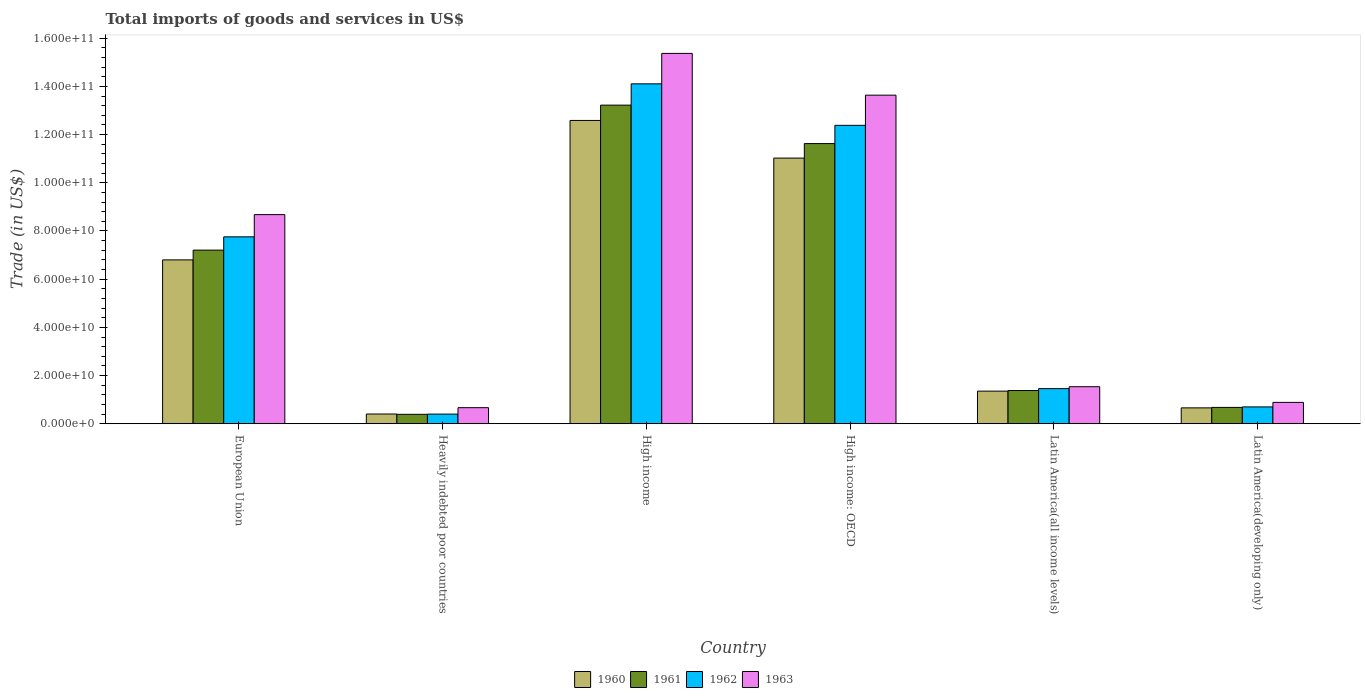Are the number of bars per tick equal to the number of legend labels?
Provide a short and direct response. Yes. Are the number of bars on each tick of the X-axis equal?
Offer a very short reply. Yes. How many bars are there on the 6th tick from the right?
Your answer should be very brief. 4. What is the label of the 5th group of bars from the left?
Your response must be concise. Latin America(all income levels). In how many cases, is the number of bars for a given country not equal to the number of legend labels?
Your response must be concise. 0. What is the total imports of goods and services in 1963 in High income: OECD?
Make the answer very short. 1.36e+11. Across all countries, what is the maximum total imports of goods and services in 1961?
Offer a very short reply. 1.32e+11. Across all countries, what is the minimum total imports of goods and services in 1963?
Ensure brevity in your answer.  6.67e+09. In which country was the total imports of goods and services in 1961 maximum?
Your response must be concise. High income. In which country was the total imports of goods and services in 1961 minimum?
Make the answer very short. Heavily indebted poor countries. What is the total total imports of goods and services in 1962 in the graph?
Provide a short and direct response. 3.68e+11. What is the difference between the total imports of goods and services in 1961 in European Union and that in High income?
Give a very brief answer. -6.02e+1. What is the difference between the total imports of goods and services in 1963 in European Union and the total imports of goods and services in 1960 in Latin America(developing only)?
Your answer should be compact. 8.02e+1. What is the average total imports of goods and services in 1962 per country?
Give a very brief answer. 6.13e+1. What is the difference between the total imports of goods and services of/in 1960 and total imports of goods and services of/in 1962 in High income: OECD?
Provide a succinct answer. -1.36e+1. In how many countries, is the total imports of goods and services in 1961 greater than 84000000000 US$?
Give a very brief answer. 2. What is the ratio of the total imports of goods and services in 1963 in European Union to that in Latin America(developing only)?
Give a very brief answer. 9.79. Is the difference between the total imports of goods and services in 1960 in European Union and Latin America(all income levels) greater than the difference between the total imports of goods and services in 1962 in European Union and Latin America(all income levels)?
Give a very brief answer. No. What is the difference between the highest and the second highest total imports of goods and services in 1962?
Offer a terse response. -1.72e+1. What is the difference between the highest and the lowest total imports of goods and services in 1963?
Your response must be concise. 1.47e+11. Is the sum of the total imports of goods and services in 1961 in High income and Latin America(all income levels) greater than the maximum total imports of goods and services in 1962 across all countries?
Offer a very short reply. Yes. Is it the case that in every country, the sum of the total imports of goods and services in 1962 and total imports of goods and services in 1960 is greater than the sum of total imports of goods and services in 1961 and total imports of goods and services in 1963?
Your response must be concise. No. What does the 3rd bar from the left in European Union represents?
Offer a very short reply. 1962. What does the 2nd bar from the right in Heavily indebted poor countries represents?
Your response must be concise. 1962. How many bars are there?
Offer a terse response. 24. How many countries are there in the graph?
Offer a very short reply. 6. Are the values on the major ticks of Y-axis written in scientific E-notation?
Keep it short and to the point. Yes. How many legend labels are there?
Offer a very short reply. 4. What is the title of the graph?
Provide a short and direct response. Total imports of goods and services in US$. What is the label or title of the Y-axis?
Your answer should be very brief. Trade (in US$). What is the Trade (in US$) of 1960 in European Union?
Your response must be concise. 6.80e+1. What is the Trade (in US$) of 1961 in European Union?
Your response must be concise. 7.21e+1. What is the Trade (in US$) of 1962 in European Union?
Keep it short and to the point. 7.76e+1. What is the Trade (in US$) in 1963 in European Union?
Your answer should be very brief. 8.68e+1. What is the Trade (in US$) of 1960 in Heavily indebted poor countries?
Offer a terse response. 4.04e+09. What is the Trade (in US$) in 1961 in Heavily indebted poor countries?
Keep it short and to the point. 3.91e+09. What is the Trade (in US$) of 1962 in Heavily indebted poor countries?
Keep it short and to the point. 4.00e+09. What is the Trade (in US$) in 1963 in Heavily indebted poor countries?
Keep it short and to the point. 6.67e+09. What is the Trade (in US$) of 1960 in High income?
Give a very brief answer. 1.26e+11. What is the Trade (in US$) of 1961 in High income?
Your answer should be very brief. 1.32e+11. What is the Trade (in US$) of 1962 in High income?
Your response must be concise. 1.41e+11. What is the Trade (in US$) of 1963 in High income?
Offer a terse response. 1.54e+11. What is the Trade (in US$) of 1960 in High income: OECD?
Your response must be concise. 1.10e+11. What is the Trade (in US$) in 1961 in High income: OECD?
Give a very brief answer. 1.16e+11. What is the Trade (in US$) in 1962 in High income: OECD?
Your answer should be very brief. 1.24e+11. What is the Trade (in US$) of 1963 in High income: OECD?
Ensure brevity in your answer.  1.36e+11. What is the Trade (in US$) in 1960 in Latin America(all income levels)?
Ensure brevity in your answer.  1.35e+1. What is the Trade (in US$) of 1961 in Latin America(all income levels)?
Your answer should be compact. 1.38e+1. What is the Trade (in US$) in 1962 in Latin America(all income levels)?
Offer a terse response. 1.46e+1. What is the Trade (in US$) in 1963 in Latin America(all income levels)?
Make the answer very short. 1.54e+1. What is the Trade (in US$) of 1960 in Latin America(developing only)?
Provide a short and direct response. 6.59e+09. What is the Trade (in US$) in 1961 in Latin America(developing only)?
Your response must be concise. 6.78e+09. What is the Trade (in US$) of 1962 in Latin America(developing only)?
Make the answer very short. 6.99e+09. What is the Trade (in US$) in 1963 in Latin America(developing only)?
Offer a terse response. 8.86e+09. Across all countries, what is the maximum Trade (in US$) in 1960?
Keep it short and to the point. 1.26e+11. Across all countries, what is the maximum Trade (in US$) of 1961?
Offer a very short reply. 1.32e+11. Across all countries, what is the maximum Trade (in US$) in 1962?
Provide a short and direct response. 1.41e+11. Across all countries, what is the maximum Trade (in US$) of 1963?
Provide a succinct answer. 1.54e+11. Across all countries, what is the minimum Trade (in US$) of 1960?
Give a very brief answer. 4.04e+09. Across all countries, what is the minimum Trade (in US$) of 1961?
Your answer should be very brief. 3.91e+09. Across all countries, what is the minimum Trade (in US$) in 1962?
Your answer should be very brief. 4.00e+09. Across all countries, what is the minimum Trade (in US$) of 1963?
Your answer should be compact. 6.67e+09. What is the total Trade (in US$) of 1960 in the graph?
Give a very brief answer. 3.28e+11. What is the total Trade (in US$) of 1961 in the graph?
Offer a terse response. 3.45e+11. What is the total Trade (in US$) of 1962 in the graph?
Your answer should be compact. 3.68e+11. What is the total Trade (in US$) in 1963 in the graph?
Your response must be concise. 4.08e+11. What is the difference between the Trade (in US$) in 1960 in European Union and that in Heavily indebted poor countries?
Give a very brief answer. 6.40e+1. What is the difference between the Trade (in US$) in 1961 in European Union and that in Heavily indebted poor countries?
Your response must be concise. 6.82e+1. What is the difference between the Trade (in US$) in 1962 in European Union and that in Heavily indebted poor countries?
Provide a short and direct response. 7.36e+1. What is the difference between the Trade (in US$) in 1963 in European Union and that in Heavily indebted poor countries?
Ensure brevity in your answer.  8.01e+1. What is the difference between the Trade (in US$) of 1960 in European Union and that in High income?
Offer a very short reply. -5.79e+1. What is the difference between the Trade (in US$) of 1961 in European Union and that in High income?
Offer a very short reply. -6.02e+1. What is the difference between the Trade (in US$) of 1962 in European Union and that in High income?
Provide a short and direct response. -6.35e+1. What is the difference between the Trade (in US$) of 1963 in European Union and that in High income?
Your response must be concise. -6.69e+1. What is the difference between the Trade (in US$) of 1960 in European Union and that in High income: OECD?
Make the answer very short. -4.23e+1. What is the difference between the Trade (in US$) of 1961 in European Union and that in High income: OECD?
Give a very brief answer. -4.42e+1. What is the difference between the Trade (in US$) of 1962 in European Union and that in High income: OECD?
Your answer should be very brief. -4.63e+1. What is the difference between the Trade (in US$) of 1963 in European Union and that in High income: OECD?
Keep it short and to the point. -4.96e+1. What is the difference between the Trade (in US$) of 1960 in European Union and that in Latin America(all income levels)?
Keep it short and to the point. 5.45e+1. What is the difference between the Trade (in US$) of 1961 in European Union and that in Latin America(all income levels)?
Keep it short and to the point. 5.83e+1. What is the difference between the Trade (in US$) in 1962 in European Union and that in Latin America(all income levels)?
Give a very brief answer. 6.30e+1. What is the difference between the Trade (in US$) in 1963 in European Union and that in Latin America(all income levels)?
Make the answer very short. 7.14e+1. What is the difference between the Trade (in US$) in 1960 in European Union and that in Latin America(developing only)?
Make the answer very short. 6.14e+1. What is the difference between the Trade (in US$) of 1961 in European Union and that in Latin America(developing only)?
Your answer should be very brief. 6.53e+1. What is the difference between the Trade (in US$) of 1962 in European Union and that in Latin America(developing only)?
Provide a short and direct response. 7.06e+1. What is the difference between the Trade (in US$) in 1963 in European Union and that in Latin America(developing only)?
Ensure brevity in your answer.  7.79e+1. What is the difference between the Trade (in US$) in 1960 in Heavily indebted poor countries and that in High income?
Give a very brief answer. -1.22e+11. What is the difference between the Trade (in US$) of 1961 in Heavily indebted poor countries and that in High income?
Keep it short and to the point. -1.28e+11. What is the difference between the Trade (in US$) of 1962 in Heavily indebted poor countries and that in High income?
Your answer should be very brief. -1.37e+11. What is the difference between the Trade (in US$) of 1963 in Heavily indebted poor countries and that in High income?
Give a very brief answer. -1.47e+11. What is the difference between the Trade (in US$) of 1960 in Heavily indebted poor countries and that in High income: OECD?
Make the answer very short. -1.06e+11. What is the difference between the Trade (in US$) of 1961 in Heavily indebted poor countries and that in High income: OECD?
Your response must be concise. -1.12e+11. What is the difference between the Trade (in US$) in 1962 in Heavily indebted poor countries and that in High income: OECD?
Your response must be concise. -1.20e+11. What is the difference between the Trade (in US$) in 1963 in Heavily indebted poor countries and that in High income: OECD?
Your response must be concise. -1.30e+11. What is the difference between the Trade (in US$) in 1960 in Heavily indebted poor countries and that in Latin America(all income levels)?
Your answer should be compact. -9.49e+09. What is the difference between the Trade (in US$) of 1961 in Heavily indebted poor countries and that in Latin America(all income levels)?
Give a very brief answer. -9.87e+09. What is the difference between the Trade (in US$) of 1962 in Heavily indebted poor countries and that in Latin America(all income levels)?
Your answer should be very brief. -1.06e+1. What is the difference between the Trade (in US$) of 1963 in Heavily indebted poor countries and that in Latin America(all income levels)?
Offer a very short reply. -8.70e+09. What is the difference between the Trade (in US$) in 1960 in Heavily indebted poor countries and that in Latin America(developing only)?
Keep it short and to the point. -2.55e+09. What is the difference between the Trade (in US$) of 1961 in Heavily indebted poor countries and that in Latin America(developing only)?
Offer a terse response. -2.87e+09. What is the difference between the Trade (in US$) of 1962 in Heavily indebted poor countries and that in Latin America(developing only)?
Your response must be concise. -2.99e+09. What is the difference between the Trade (in US$) of 1963 in Heavily indebted poor countries and that in Latin America(developing only)?
Your response must be concise. -2.20e+09. What is the difference between the Trade (in US$) of 1960 in High income and that in High income: OECD?
Your answer should be very brief. 1.56e+1. What is the difference between the Trade (in US$) in 1961 in High income and that in High income: OECD?
Give a very brief answer. 1.60e+1. What is the difference between the Trade (in US$) in 1962 in High income and that in High income: OECD?
Ensure brevity in your answer.  1.72e+1. What is the difference between the Trade (in US$) of 1963 in High income and that in High income: OECD?
Provide a succinct answer. 1.73e+1. What is the difference between the Trade (in US$) of 1960 in High income and that in Latin America(all income levels)?
Offer a very short reply. 1.12e+11. What is the difference between the Trade (in US$) in 1961 in High income and that in Latin America(all income levels)?
Make the answer very short. 1.18e+11. What is the difference between the Trade (in US$) in 1962 in High income and that in Latin America(all income levels)?
Offer a terse response. 1.26e+11. What is the difference between the Trade (in US$) of 1963 in High income and that in Latin America(all income levels)?
Offer a very short reply. 1.38e+11. What is the difference between the Trade (in US$) of 1960 in High income and that in Latin America(developing only)?
Ensure brevity in your answer.  1.19e+11. What is the difference between the Trade (in US$) of 1961 in High income and that in Latin America(developing only)?
Offer a very short reply. 1.25e+11. What is the difference between the Trade (in US$) of 1962 in High income and that in Latin America(developing only)?
Your response must be concise. 1.34e+11. What is the difference between the Trade (in US$) of 1963 in High income and that in Latin America(developing only)?
Provide a succinct answer. 1.45e+11. What is the difference between the Trade (in US$) of 1960 in High income: OECD and that in Latin America(all income levels)?
Your answer should be compact. 9.67e+1. What is the difference between the Trade (in US$) in 1961 in High income: OECD and that in Latin America(all income levels)?
Keep it short and to the point. 1.02e+11. What is the difference between the Trade (in US$) of 1962 in High income: OECD and that in Latin America(all income levels)?
Offer a very short reply. 1.09e+11. What is the difference between the Trade (in US$) in 1963 in High income: OECD and that in Latin America(all income levels)?
Make the answer very short. 1.21e+11. What is the difference between the Trade (in US$) in 1960 in High income: OECD and that in Latin America(developing only)?
Provide a short and direct response. 1.04e+11. What is the difference between the Trade (in US$) of 1961 in High income: OECD and that in Latin America(developing only)?
Provide a short and direct response. 1.09e+11. What is the difference between the Trade (in US$) of 1962 in High income: OECD and that in Latin America(developing only)?
Keep it short and to the point. 1.17e+11. What is the difference between the Trade (in US$) of 1963 in High income: OECD and that in Latin America(developing only)?
Your answer should be very brief. 1.28e+11. What is the difference between the Trade (in US$) of 1960 in Latin America(all income levels) and that in Latin America(developing only)?
Give a very brief answer. 6.94e+09. What is the difference between the Trade (in US$) in 1961 in Latin America(all income levels) and that in Latin America(developing only)?
Your answer should be very brief. 7.00e+09. What is the difference between the Trade (in US$) of 1962 in Latin America(all income levels) and that in Latin America(developing only)?
Ensure brevity in your answer.  7.59e+09. What is the difference between the Trade (in US$) in 1963 in Latin America(all income levels) and that in Latin America(developing only)?
Your answer should be very brief. 6.50e+09. What is the difference between the Trade (in US$) in 1960 in European Union and the Trade (in US$) in 1961 in Heavily indebted poor countries?
Ensure brevity in your answer.  6.41e+1. What is the difference between the Trade (in US$) of 1960 in European Union and the Trade (in US$) of 1962 in Heavily indebted poor countries?
Provide a short and direct response. 6.40e+1. What is the difference between the Trade (in US$) of 1960 in European Union and the Trade (in US$) of 1963 in Heavily indebted poor countries?
Offer a very short reply. 6.13e+1. What is the difference between the Trade (in US$) in 1961 in European Union and the Trade (in US$) in 1962 in Heavily indebted poor countries?
Your response must be concise. 6.81e+1. What is the difference between the Trade (in US$) in 1961 in European Union and the Trade (in US$) in 1963 in Heavily indebted poor countries?
Your answer should be compact. 6.54e+1. What is the difference between the Trade (in US$) of 1962 in European Union and the Trade (in US$) of 1963 in Heavily indebted poor countries?
Ensure brevity in your answer.  7.09e+1. What is the difference between the Trade (in US$) in 1960 in European Union and the Trade (in US$) in 1961 in High income?
Offer a very short reply. -6.42e+1. What is the difference between the Trade (in US$) of 1960 in European Union and the Trade (in US$) of 1962 in High income?
Offer a terse response. -7.31e+1. What is the difference between the Trade (in US$) of 1960 in European Union and the Trade (in US$) of 1963 in High income?
Keep it short and to the point. -8.57e+1. What is the difference between the Trade (in US$) in 1961 in European Union and the Trade (in US$) in 1962 in High income?
Offer a terse response. -6.90e+1. What is the difference between the Trade (in US$) in 1961 in European Union and the Trade (in US$) in 1963 in High income?
Keep it short and to the point. -8.16e+1. What is the difference between the Trade (in US$) of 1962 in European Union and the Trade (in US$) of 1963 in High income?
Your answer should be very brief. -7.61e+1. What is the difference between the Trade (in US$) in 1960 in European Union and the Trade (in US$) in 1961 in High income: OECD?
Provide a succinct answer. -4.83e+1. What is the difference between the Trade (in US$) of 1960 in European Union and the Trade (in US$) of 1962 in High income: OECD?
Your answer should be very brief. -5.58e+1. What is the difference between the Trade (in US$) of 1960 in European Union and the Trade (in US$) of 1963 in High income: OECD?
Your answer should be compact. -6.84e+1. What is the difference between the Trade (in US$) of 1961 in European Union and the Trade (in US$) of 1962 in High income: OECD?
Your answer should be very brief. -5.18e+1. What is the difference between the Trade (in US$) in 1961 in European Union and the Trade (in US$) in 1963 in High income: OECD?
Your answer should be very brief. -6.43e+1. What is the difference between the Trade (in US$) of 1962 in European Union and the Trade (in US$) of 1963 in High income: OECD?
Ensure brevity in your answer.  -5.88e+1. What is the difference between the Trade (in US$) in 1960 in European Union and the Trade (in US$) in 1961 in Latin America(all income levels)?
Offer a very short reply. 5.42e+1. What is the difference between the Trade (in US$) in 1960 in European Union and the Trade (in US$) in 1962 in Latin America(all income levels)?
Your response must be concise. 5.34e+1. What is the difference between the Trade (in US$) in 1960 in European Union and the Trade (in US$) in 1963 in Latin America(all income levels)?
Give a very brief answer. 5.26e+1. What is the difference between the Trade (in US$) of 1961 in European Union and the Trade (in US$) of 1962 in Latin America(all income levels)?
Your answer should be compact. 5.75e+1. What is the difference between the Trade (in US$) of 1961 in European Union and the Trade (in US$) of 1963 in Latin America(all income levels)?
Your response must be concise. 5.67e+1. What is the difference between the Trade (in US$) in 1962 in European Union and the Trade (in US$) in 1963 in Latin America(all income levels)?
Provide a succinct answer. 6.22e+1. What is the difference between the Trade (in US$) in 1960 in European Union and the Trade (in US$) in 1961 in Latin America(developing only)?
Offer a very short reply. 6.12e+1. What is the difference between the Trade (in US$) of 1960 in European Union and the Trade (in US$) of 1962 in Latin America(developing only)?
Keep it short and to the point. 6.10e+1. What is the difference between the Trade (in US$) of 1960 in European Union and the Trade (in US$) of 1963 in Latin America(developing only)?
Provide a short and direct response. 5.91e+1. What is the difference between the Trade (in US$) in 1961 in European Union and the Trade (in US$) in 1962 in Latin America(developing only)?
Ensure brevity in your answer.  6.51e+1. What is the difference between the Trade (in US$) in 1961 in European Union and the Trade (in US$) in 1963 in Latin America(developing only)?
Offer a terse response. 6.32e+1. What is the difference between the Trade (in US$) in 1962 in European Union and the Trade (in US$) in 1963 in Latin America(developing only)?
Keep it short and to the point. 6.87e+1. What is the difference between the Trade (in US$) of 1960 in Heavily indebted poor countries and the Trade (in US$) of 1961 in High income?
Provide a succinct answer. -1.28e+11. What is the difference between the Trade (in US$) in 1960 in Heavily indebted poor countries and the Trade (in US$) in 1962 in High income?
Ensure brevity in your answer.  -1.37e+11. What is the difference between the Trade (in US$) in 1960 in Heavily indebted poor countries and the Trade (in US$) in 1963 in High income?
Keep it short and to the point. -1.50e+11. What is the difference between the Trade (in US$) in 1961 in Heavily indebted poor countries and the Trade (in US$) in 1962 in High income?
Give a very brief answer. -1.37e+11. What is the difference between the Trade (in US$) in 1961 in Heavily indebted poor countries and the Trade (in US$) in 1963 in High income?
Your answer should be very brief. -1.50e+11. What is the difference between the Trade (in US$) in 1962 in Heavily indebted poor countries and the Trade (in US$) in 1963 in High income?
Offer a very short reply. -1.50e+11. What is the difference between the Trade (in US$) of 1960 in Heavily indebted poor countries and the Trade (in US$) of 1961 in High income: OECD?
Offer a terse response. -1.12e+11. What is the difference between the Trade (in US$) of 1960 in Heavily indebted poor countries and the Trade (in US$) of 1962 in High income: OECD?
Provide a short and direct response. -1.20e+11. What is the difference between the Trade (in US$) of 1960 in Heavily indebted poor countries and the Trade (in US$) of 1963 in High income: OECD?
Provide a short and direct response. -1.32e+11. What is the difference between the Trade (in US$) in 1961 in Heavily indebted poor countries and the Trade (in US$) in 1962 in High income: OECD?
Keep it short and to the point. -1.20e+11. What is the difference between the Trade (in US$) of 1961 in Heavily indebted poor countries and the Trade (in US$) of 1963 in High income: OECD?
Offer a terse response. -1.32e+11. What is the difference between the Trade (in US$) of 1962 in Heavily indebted poor countries and the Trade (in US$) of 1963 in High income: OECD?
Provide a short and direct response. -1.32e+11. What is the difference between the Trade (in US$) in 1960 in Heavily indebted poor countries and the Trade (in US$) in 1961 in Latin America(all income levels)?
Give a very brief answer. -9.74e+09. What is the difference between the Trade (in US$) of 1960 in Heavily indebted poor countries and the Trade (in US$) of 1962 in Latin America(all income levels)?
Your response must be concise. -1.05e+1. What is the difference between the Trade (in US$) of 1960 in Heavily indebted poor countries and the Trade (in US$) of 1963 in Latin America(all income levels)?
Offer a terse response. -1.13e+1. What is the difference between the Trade (in US$) of 1961 in Heavily indebted poor countries and the Trade (in US$) of 1962 in Latin America(all income levels)?
Offer a very short reply. -1.07e+1. What is the difference between the Trade (in US$) in 1961 in Heavily indebted poor countries and the Trade (in US$) in 1963 in Latin America(all income levels)?
Your answer should be very brief. -1.15e+1. What is the difference between the Trade (in US$) of 1962 in Heavily indebted poor countries and the Trade (in US$) of 1963 in Latin America(all income levels)?
Ensure brevity in your answer.  -1.14e+1. What is the difference between the Trade (in US$) of 1960 in Heavily indebted poor countries and the Trade (in US$) of 1961 in Latin America(developing only)?
Give a very brief answer. -2.74e+09. What is the difference between the Trade (in US$) in 1960 in Heavily indebted poor countries and the Trade (in US$) in 1962 in Latin America(developing only)?
Offer a very short reply. -2.95e+09. What is the difference between the Trade (in US$) in 1960 in Heavily indebted poor countries and the Trade (in US$) in 1963 in Latin America(developing only)?
Your answer should be compact. -4.82e+09. What is the difference between the Trade (in US$) of 1961 in Heavily indebted poor countries and the Trade (in US$) of 1962 in Latin America(developing only)?
Your response must be concise. -3.08e+09. What is the difference between the Trade (in US$) in 1961 in Heavily indebted poor countries and the Trade (in US$) in 1963 in Latin America(developing only)?
Make the answer very short. -4.95e+09. What is the difference between the Trade (in US$) in 1962 in Heavily indebted poor countries and the Trade (in US$) in 1963 in Latin America(developing only)?
Ensure brevity in your answer.  -4.86e+09. What is the difference between the Trade (in US$) in 1960 in High income and the Trade (in US$) in 1961 in High income: OECD?
Provide a succinct answer. 9.60e+09. What is the difference between the Trade (in US$) in 1960 in High income and the Trade (in US$) in 1962 in High income: OECD?
Provide a succinct answer. 2.03e+09. What is the difference between the Trade (in US$) in 1960 in High income and the Trade (in US$) in 1963 in High income: OECD?
Your answer should be compact. -1.05e+1. What is the difference between the Trade (in US$) of 1961 in High income and the Trade (in US$) of 1962 in High income: OECD?
Your response must be concise. 8.39e+09. What is the difference between the Trade (in US$) in 1961 in High income and the Trade (in US$) in 1963 in High income: OECD?
Offer a terse response. -4.14e+09. What is the difference between the Trade (in US$) of 1962 in High income and the Trade (in US$) of 1963 in High income: OECD?
Offer a terse response. 4.70e+09. What is the difference between the Trade (in US$) in 1960 in High income and the Trade (in US$) in 1961 in Latin America(all income levels)?
Offer a very short reply. 1.12e+11. What is the difference between the Trade (in US$) of 1960 in High income and the Trade (in US$) of 1962 in Latin America(all income levels)?
Make the answer very short. 1.11e+11. What is the difference between the Trade (in US$) in 1960 in High income and the Trade (in US$) in 1963 in Latin America(all income levels)?
Provide a short and direct response. 1.11e+11. What is the difference between the Trade (in US$) in 1961 in High income and the Trade (in US$) in 1962 in Latin America(all income levels)?
Provide a short and direct response. 1.18e+11. What is the difference between the Trade (in US$) in 1961 in High income and the Trade (in US$) in 1963 in Latin America(all income levels)?
Make the answer very short. 1.17e+11. What is the difference between the Trade (in US$) of 1962 in High income and the Trade (in US$) of 1963 in Latin America(all income levels)?
Offer a very short reply. 1.26e+11. What is the difference between the Trade (in US$) in 1960 in High income and the Trade (in US$) in 1961 in Latin America(developing only)?
Your answer should be compact. 1.19e+11. What is the difference between the Trade (in US$) in 1960 in High income and the Trade (in US$) in 1962 in Latin America(developing only)?
Your response must be concise. 1.19e+11. What is the difference between the Trade (in US$) of 1960 in High income and the Trade (in US$) of 1963 in Latin America(developing only)?
Give a very brief answer. 1.17e+11. What is the difference between the Trade (in US$) in 1961 in High income and the Trade (in US$) in 1962 in Latin America(developing only)?
Provide a short and direct response. 1.25e+11. What is the difference between the Trade (in US$) of 1961 in High income and the Trade (in US$) of 1963 in Latin America(developing only)?
Give a very brief answer. 1.23e+11. What is the difference between the Trade (in US$) in 1962 in High income and the Trade (in US$) in 1963 in Latin America(developing only)?
Keep it short and to the point. 1.32e+11. What is the difference between the Trade (in US$) in 1960 in High income: OECD and the Trade (in US$) in 1961 in Latin America(all income levels)?
Your answer should be very brief. 9.65e+1. What is the difference between the Trade (in US$) in 1960 in High income: OECD and the Trade (in US$) in 1962 in Latin America(all income levels)?
Ensure brevity in your answer.  9.57e+1. What is the difference between the Trade (in US$) in 1960 in High income: OECD and the Trade (in US$) in 1963 in Latin America(all income levels)?
Your answer should be compact. 9.49e+1. What is the difference between the Trade (in US$) of 1961 in High income: OECD and the Trade (in US$) of 1962 in Latin America(all income levels)?
Your answer should be very brief. 1.02e+11. What is the difference between the Trade (in US$) of 1961 in High income: OECD and the Trade (in US$) of 1963 in Latin America(all income levels)?
Make the answer very short. 1.01e+11. What is the difference between the Trade (in US$) in 1962 in High income: OECD and the Trade (in US$) in 1963 in Latin America(all income levels)?
Provide a succinct answer. 1.08e+11. What is the difference between the Trade (in US$) in 1960 in High income: OECD and the Trade (in US$) in 1961 in Latin America(developing only)?
Ensure brevity in your answer.  1.03e+11. What is the difference between the Trade (in US$) in 1960 in High income: OECD and the Trade (in US$) in 1962 in Latin America(developing only)?
Offer a very short reply. 1.03e+11. What is the difference between the Trade (in US$) of 1960 in High income: OECD and the Trade (in US$) of 1963 in Latin America(developing only)?
Your answer should be very brief. 1.01e+11. What is the difference between the Trade (in US$) of 1961 in High income: OECD and the Trade (in US$) of 1962 in Latin America(developing only)?
Ensure brevity in your answer.  1.09e+11. What is the difference between the Trade (in US$) in 1961 in High income: OECD and the Trade (in US$) in 1963 in Latin America(developing only)?
Keep it short and to the point. 1.07e+11. What is the difference between the Trade (in US$) in 1962 in High income: OECD and the Trade (in US$) in 1963 in Latin America(developing only)?
Offer a very short reply. 1.15e+11. What is the difference between the Trade (in US$) of 1960 in Latin America(all income levels) and the Trade (in US$) of 1961 in Latin America(developing only)?
Provide a short and direct response. 6.75e+09. What is the difference between the Trade (in US$) of 1960 in Latin America(all income levels) and the Trade (in US$) of 1962 in Latin America(developing only)?
Offer a very short reply. 6.55e+09. What is the difference between the Trade (in US$) in 1960 in Latin America(all income levels) and the Trade (in US$) in 1963 in Latin America(developing only)?
Keep it short and to the point. 4.67e+09. What is the difference between the Trade (in US$) of 1961 in Latin America(all income levels) and the Trade (in US$) of 1962 in Latin America(developing only)?
Your answer should be very brief. 6.79e+09. What is the difference between the Trade (in US$) in 1961 in Latin America(all income levels) and the Trade (in US$) in 1963 in Latin America(developing only)?
Offer a very short reply. 4.92e+09. What is the difference between the Trade (in US$) of 1962 in Latin America(all income levels) and the Trade (in US$) of 1963 in Latin America(developing only)?
Offer a terse response. 5.72e+09. What is the average Trade (in US$) of 1960 per country?
Provide a succinct answer. 5.47e+1. What is the average Trade (in US$) in 1961 per country?
Ensure brevity in your answer.  5.75e+1. What is the average Trade (in US$) in 1962 per country?
Keep it short and to the point. 6.13e+1. What is the average Trade (in US$) in 1963 per country?
Ensure brevity in your answer.  6.80e+1. What is the difference between the Trade (in US$) of 1960 and Trade (in US$) of 1961 in European Union?
Your response must be concise. -4.05e+09. What is the difference between the Trade (in US$) in 1960 and Trade (in US$) in 1962 in European Union?
Give a very brief answer. -9.57e+09. What is the difference between the Trade (in US$) of 1960 and Trade (in US$) of 1963 in European Union?
Provide a succinct answer. -1.88e+1. What is the difference between the Trade (in US$) in 1961 and Trade (in US$) in 1962 in European Union?
Offer a very short reply. -5.51e+09. What is the difference between the Trade (in US$) of 1961 and Trade (in US$) of 1963 in European Union?
Your answer should be very brief. -1.47e+1. What is the difference between the Trade (in US$) in 1962 and Trade (in US$) in 1963 in European Union?
Your answer should be compact. -9.22e+09. What is the difference between the Trade (in US$) in 1960 and Trade (in US$) in 1961 in Heavily indebted poor countries?
Your response must be concise. 1.30e+08. What is the difference between the Trade (in US$) in 1960 and Trade (in US$) in 1962 in Heavily indebted poor countries?
Give a very brief answer. 3.87e+07. What is the difference between the Trade (in US$) in 1960 and Trade (in US$) in 1963 in Heavily indebted poor countries?
Provide a short and direct response. -2.63e+09. What is the difference between the Trade (in US$) of 1961 and Trade (in US$) of 1962 in Heavily indebted poor countries?
Offer a terse response. -9.18e+07. What is the difference between the Trade (in US$) in 1961 and Trade (in US$) in 1963 in Heavily indebted poor countries?
Your response must be concise. -2.76e+09. What is the difference between the Trade (in US$) of 1962 and Trade (in US$) of 1963 in Heavily indebted poor countries?
Make the answer very short. -2.67e+09. What is the difference between the Trade (in US$) of 1960 and Trade (in US$) of 1961 in High income?
Offer a terse response. -6.36e+09. What is the difference between the Trade (in US$) of 1960 and Trade (in US$) of 1962 in High income?
Your answer should be very brief. -1.52e+1. What is the difference between the Trade (in US$) of 1960 and Trade (in US$) of 1963 in High income?
Offer a terse response. -2.78e+1. What is the difference between the Trade (in US$) of 1961 and Trade (in US$) of 1962 in High income?
Offer a terse response. -8.84e+09. What is the difference between the Trade (in US$) in 1961 and Trade (in US$) in 1963 in High income?
Provide a short and direct response. -2.15e+1. What is the difference between the Trade (in US$) of 1962 and Trade (in US$) of 1963 in High income?
Your answer should be very brief. -1.26e+1. What is the difference between the Trade (in US$) of 1960 and Trade (in US$) of 1961 in High income: OECD?
Keep it short and to the point. -6.02e+09. What is the difference between the Trade (in US$) in 1960 and Trade (in US$) in 1962 in High income: OECD?
Offer a terse response. -1.36e+1. What is the difference between the Trade (in US$) in 1960 and Trade (in US$) in 1963 in High income: OECD?
Provide a succinct answer. -2.61e+1. What is the difference between the Trade (in US$) in 1961 and Trade (in US$) in 1962 in High income: OECD?
Offer a very short reply. -7.57e+09. What is the difference between the Trade (in US$) in 1961 and Trade (in US$) in 1963 in High income: OECD?
Keep it short and to the point. -2.01e+1. What is the difference between the Trade (in US$) in 1962 and Trade (in US$) in 1963 in High income: OECD?
Provide a short and direct response. -1.25e+1. What is the difference between the Trade (in US$) in 1960 and Trade (in US$) in 1961 in Latin America(all income levels)?
Make the answer very short. -2.48e+08. What is the difference between the Trade (in US$) in 1960 and Trade (in US$) in 1962 in Latin America(all income levels)?
Provide a short and direct response. -1.05e+09. What is the difference between the Trade (in US$) in 1960 and Trade (in US$) in 1963 in Latin America(all income levels)?
Offer a terse response. -1.83e+09. What is the difference between the Trade (in US$) of 1961 and Trade (in US$) of 1962 in Latin America(all income levels)?
Your answer should be very brief. -7.99e+08. What is the difference between the Trade (in US$) in 1961 and Trade (in US$) in 1963 in Latin America(all income levels)?
Give a very brief answer. -1.59e+09. What is the difference between the Trade (in US$) of 1962 and Trade (in US$) of 1963 in Latin America(all income levels)?
Make the answer very short. -7.87e+08. What is the difference between the Trade (in US$) in 1960 and Trade (in US$) in 1961 in Latin America(developing only)?
Keep it short and to the point. -1.91e+08. What is the difference between the Trade (in US$) of 1960 and Trade (in US$) of 1962 in Latin America(developing only)?
Provide a short and direct response. -3.96e+08. What is the difference between the Trade (in US$) in 1960 and Trade (in US$) in 1963 in Latin America(developing only)?
Your answer should be compact. -2.27e+09. What is the difference between the Trade (in US$) of 1961 and Trade (in US$) of 1962 in Latin America(developing only)?
Provide a succinct answer. -2.05e+08. What is the difference between the Trade (in US$) in 1961 and Trade (in US$) in 1963 in Latin America(developing only)?
Your answer should be compact. -2.08e+09. What is the difference between the Trade (in US$) of 1962 and Trade (in US$) of 1963 in Latin America(developing only)?
Offer a very short reply. -1.88e+09. What is the ratio of the Trade (in US$) of 1960 in European Union to that in Heavily indebted poor countries?
Ensure brevity in your answer.  16.84. What is the ratio of the Trade (in US$) of 1961 in European Union to that in Heavily indebted poor countries?
Provide a short and direct response. 18.44. What is the ratio of the Trade (in US$) of 1962 in European Union to that in Heavily indebted poor countries?
Your response must be concise. 19.4. What is the ratio of the Trade (in US$) in 1963 in European Union to that in Heavily indebted poor countries?
Your response must be concise. 13.02. What is the ratio of the Trade (in US$) of 1960 in European Union to that in High income?
Your response must be concise. 0.54. What is the ratio of the Trade (in US$) of 1961 in European Union to that in High income?
Keep it short and to the point. 0.54. What is the ratio of the Trade (in US$) of 1962 in European Union to that in High income?
Your response must be concise. 0.55. What is the ratio of the Trade (in US$) in 1963 in European Union to that in High income?
Give a very brief answer. 0.56. What is the ratio of the Trade (in US$) in 1960 in European Union to that in High income: OECD?
Your answer should be compact. 0.62. What is the ratio of the Trade (in US$) of 1961 in European Union to that in High income: OECD?
Your answer should be compact. 0.62. What is the ratio of the Trade (in US$) of 1962 in European Union to that in High income: OECD?
Your response must be concise. 0.63. What is the ratio of the Trade (in US$) of 1963 in European Union to that in High income: OECD?
Offer a very short reply. 0.64. What is the ratio of the Trade (in US$) in 1960 in European Union to that in Latin America(all income levels)?
Provide a short and direct response. 5.03. What is the ratio of the Trade (in US$) of 1961 in European Union to that in Latin America(all income levels)?
Your answer should be compact. 5.23. What is the ratio of the Trade (in US$) in 1962 in European Union to that in Latin America(all income levels)?
Make the answer very short. 5.32. What is the ratio of the Trade (in US$) of 1963 in European Union to that in Latin America(all income levels)?
Provide a short and direct response. 5.65. What is the ratio of the Trade (in US$) of 1960 in European Union to that in Latin America(developing only)?
Provide a short and direct response. 10.32. What is the ratio of the Trade (in US$) of 1961 in European Union to that in Latin America(developing only)?
Give a very brief answer. 10.63. What is the ratio of the Trade (in US$) in 1962 in European Union to that in Latin America(developing only)?
Make the answer very short. 11.1. What is the ratio of the Trade (in US$) in 1963 in European Union to that in Latin America(developing only)?
Your answer should be compact. 9.79. What is the ratio of the Trade (in US$) of 1960 in Heavily indebted poor countries to that in High income?
Give a very brief answer. 0.03. What is the ratio of the Trade (in US$) in 1961 in Heavily indebted poor countries to that in High income?
Your answer should be compact. 0.03. What is the ratio of the Trade (in US$) of 1962 in Heavily indebted poor countries to that in High income?
Keep it short and to the point. 0.03. What is the ratio of the Trade (in US$) in 1963 in Heavily indebted poor countries to that in High income?
Offer a very short reply. 0.04. What is the ratio of the Trade (in US$) in 1960 in Heavily indebted poor countries to that in High income: OECD?
Your answer should be compact. 0.04. What is the ratio of the Trade (in US$) in 1961 in Heavily indebted poor countries to that in High income: OECD?
Keep it short and to the point. 0.03. What is the ratio of the Trade (in US$) of 1962 in Heavily indebted poor countries to that in High income: OECD?
Your answer should be compact. 0.03. What is the ratio of the Trade (in US$) in 1963 in Heavily indebted poor countries to that in High income: OECD?
Make the answer very short. 0.05. What is the ratio of the Trade (in US$) of 1960 in Heavily indebted poor countries to that in Latin America(all income levels)?
Your answer should be compact. 0.3. What is the ratio of the Trade (in US$) in 1961 in Heavily indebted poor countries to that in Latin America(all income levels)?
Keep it short and to the point. 0.28. What is the ratio of the Trade (in US$) in 1962 in Heavily indebted poor countries to that in Latin America(all income levels)?
Provide a short and direct response. 0.27. What is the ratio of the Trade (in US$) in 1963 in Heavily indebted poor countries to that in Latin America(all income levels)?
Offer a terse response. 0.43. What is the ratio of the Trade (in US$) in 1960 in Heavily indebted poor countries to that in Latin America(developing only)?
Your answer should be very brief. 0.61. What is the ratio of the Trade (in US$) of 1961 in Heavily indebted poor countries to that in Latin America(developing only)?
Your response must be concise. 0.58. What is the ratio of the Trade (in US$) in 1962 in Heavily indebted poor countries to that in Latin America(developing only)?
Provide a short and direct response. 0.57. What is the ratio of the Trade (in US$) in 1963 in Heavily indebted poor countries to that in Latin America(developing only)?
Your response must be concise. 0.75. What is the ratio of the Trade (in US$) in 1960 in High income to that in High income: OECD?
Ensure brevity in your answer.  1.14. What is the ratio of the Trade (in US$) of 1961 in High income to that in High income: OECD?
Your answer should be very brief. 1.14. What is the ratio of the Trade (in US$) of 1962 in High income to that in High income: OECD?
Provide a succinct answer. 1.14. What is the ratio of the Trade (in US$) in 1963 in High income to that in High income: OECD?
Your answer should be compact. 1.13. What is the ratio of the Trade (in US$) of 1960 in High income to that in Latin America(all income levels)?
Offer a terse response. 9.3. What is the ratio of the Trade (in US$) in 1961 in High income to that in Latin America(all income levels)?
Provide a succinct answer. 9.6. What is the ratio of the Trade (in US$) of 1962 in High income to that in Latin America(all income levels)?
Ensure brevity in your answer.  9.68. What is the ratio of the Trade (in US$) in 1963 in High income to that in Latin America(all income levels)?
Keep it short and to the point. 10. What is the ratio of the Trade (in US$) of 1960 in High income to that in Latin America(developing only)?
Offer a terse response. 19.1. What is the ratio of the Trade (in US$) of 1961 in High income to that in Latin America(developing only)?
Your answer should be compact. 19.5. What is the ratio of the Trade (in US$) in 1962 in High income to that in Latin America(developing only)?
Ensure brevity in your answer.  20.19. What is the ratio of the Trade (in US$) of 1963 in High income to that in Latin America(developing only)?
Keep it short and to the point. 17.34. What is the ratio of the Trade (in US$) in 1960 in High income: OECD to that in Latin America(all income levels)?
Your answer should be compact. 8.15. What is the ratio of the Trade (in US$) in 1961 in High income: OECD to that in Latin America(all income levels)?
Offer a terse response. 8.44. What is the ratio of the Trade (in US$) in 1962 in High income: OECD to that in Latin America(all income levels)?
Ensure brevity in your answer.  8.49. What is the ratio of the Trade (in US$) of 1963 in High income: OECD to that in Latin America(all income levels)?
Your answer should be very brief. 8.87. What is the ratio of the Trade (in US$) of 1960 in High income: OECD to that in Latin America(developing only)?
Your answer should be compact. 16.73. What is the ratio of the Trade (in US$) of 1961 in High income: OECD to that in Latin America(developing only)?
Your answer should be compact. 17.15. What is the ratio of the Trade (in US$) in 1962 in High income: OECD to that in Latin America(developing only)?
Your response must be concise. 17.73. What is the ratio of the Trade (in US$) in 1963 in High income: OECD to that in Latin America(developing only)?
Your response must be concise. 15.39. What is the ratio of the Trade (in US$) in 1960 in Latin America(all income levels) to that in Latin America(developing only)?
Ensure brevity in your answer.  2.05. What is the ratio of the Trade (in US$) in 1961 in Latin America(all income levels) to that in Latin America(developing only)?
Give a very brief answer. 2.03. What is the ratio of the Trade (in US$) in 1962 in Latin America(all income levels) to that in Latin America(developing only)?
Provide a succinct answer. 2.09. What is the ratio of the Trade (in US$) of 1963 in Latin America(all income levels) to that in Latin America(developing only)?
Offer a terse response. 1.73. What is the difference between the highest and the second highest Trade (in US$) of 1960?
Keep it short and to the point. 1.56e+1. What is the difference between the highest and the second highest Trade (in US$) in 1961?
Make the answer very short. 1.60e+1. What is the difference between the highest and the second highest Trade (in US$) in 1962?
Make the answer very short. 1.72e+1. What is the difference between the highest and the second highest Trade (in US$) of 1963?
Your answer should be very brief. 1.73e+1. What is the difference between the highest and the lowest Trade (in US$) in 1960?
Keep it short and to the point. 1.22e+11. What is the difference between the highest and the lowest Trade (in US$) of 1961?
Provide a succinct answer. 1.28e+11. What is the difference between the highest and the lowest Trade (in US$) in 1962?
Offer a terse response. 1.37e+11. What is the difference between the highest and the lowest Trade (in US$) of 1963?
Your answer should be very brief. 1.47e+11. 